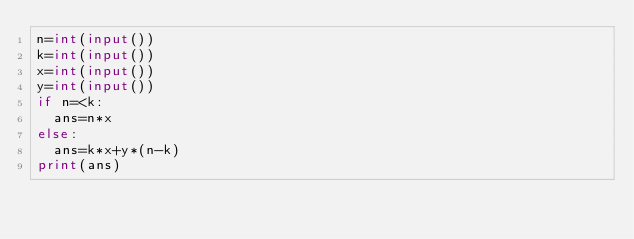Convert code to text. <code><loc_0><loc_0><loc_500><loc_500><_Python_>n=int(input())
k=int(input())
x=int(input())
y=int(input())
if n=<k:
  ans=n*x
else:
  ans=k*x+y*(n-k)
print(ans)</code> 